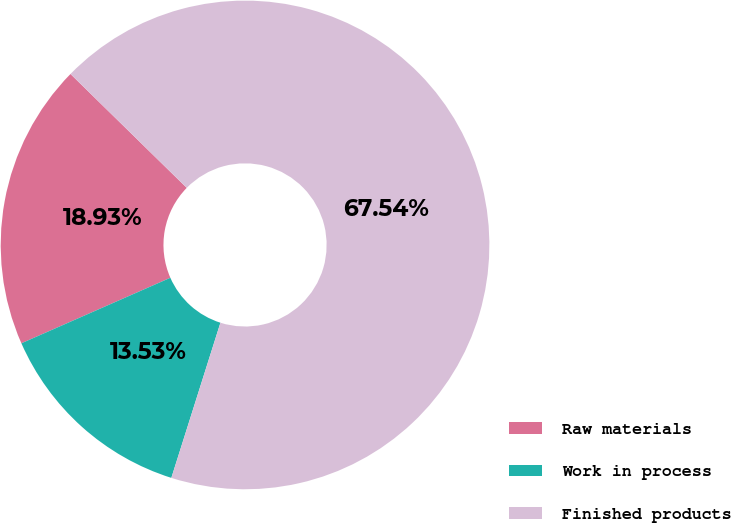Convert chart to OTSL. <chart><loc_0><loc_0><loc_500><loc_500><pie_chart><fcel>Raw materials<fcel>Work in process<fcel>Finished products<nl><fcel>18.93%<fcel>13.53%<fcel>67.55%<nl></chart> 